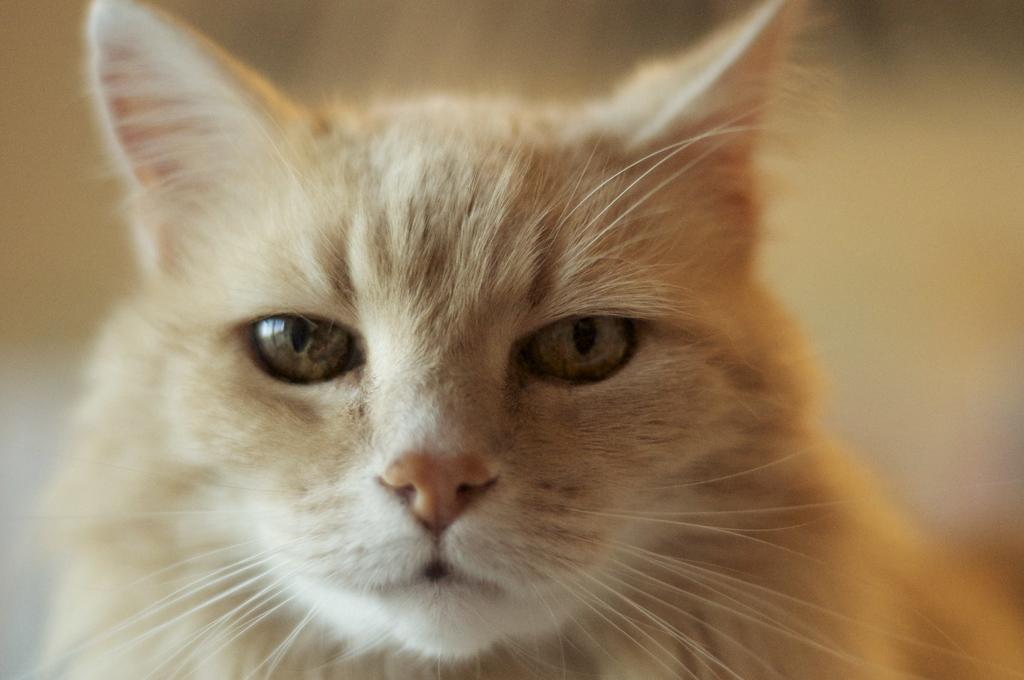In one or two sentences, can you explain what this image depicts? In this image we can see a cat. 